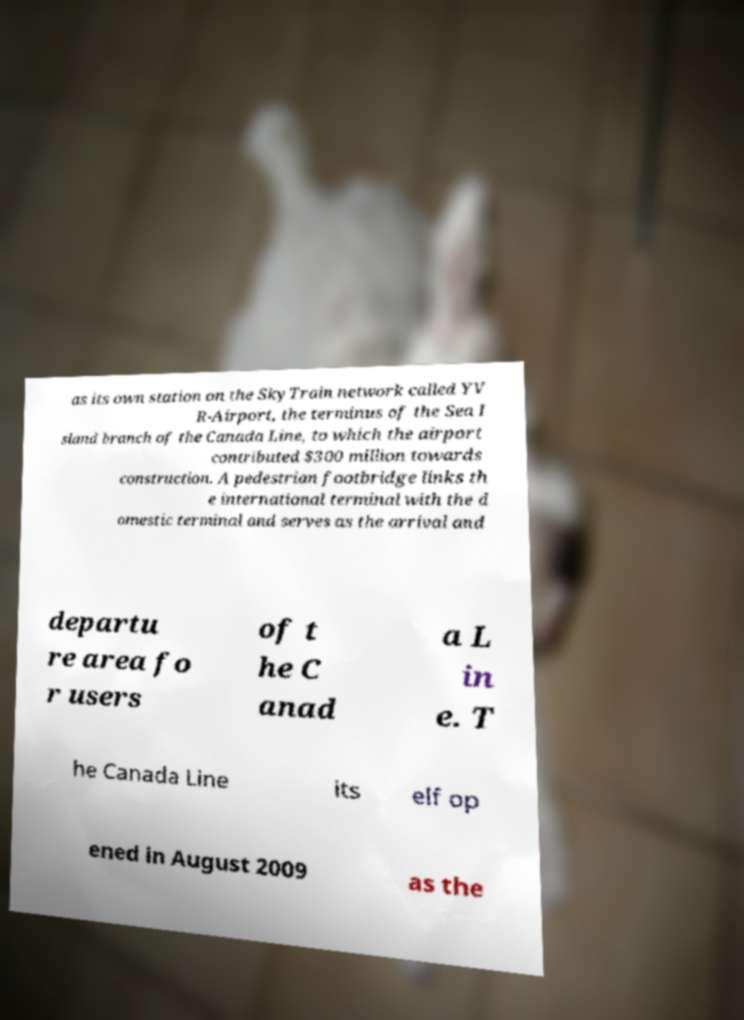I need the written content from this picture converted into text. Can you do that? as its own station on the SkyTrain network called YV R-Airport, the terminus of the Sea I sland branch of the Canada Line, to which the airport contributed $300 million towards construction. A pedestrian footbridge links th e international terminal with the d omestic terminal and serves as the arrival and departu re area fo r users of t he C anad a L in e. T he Canada Line its elf op ened in August 2009 as the 